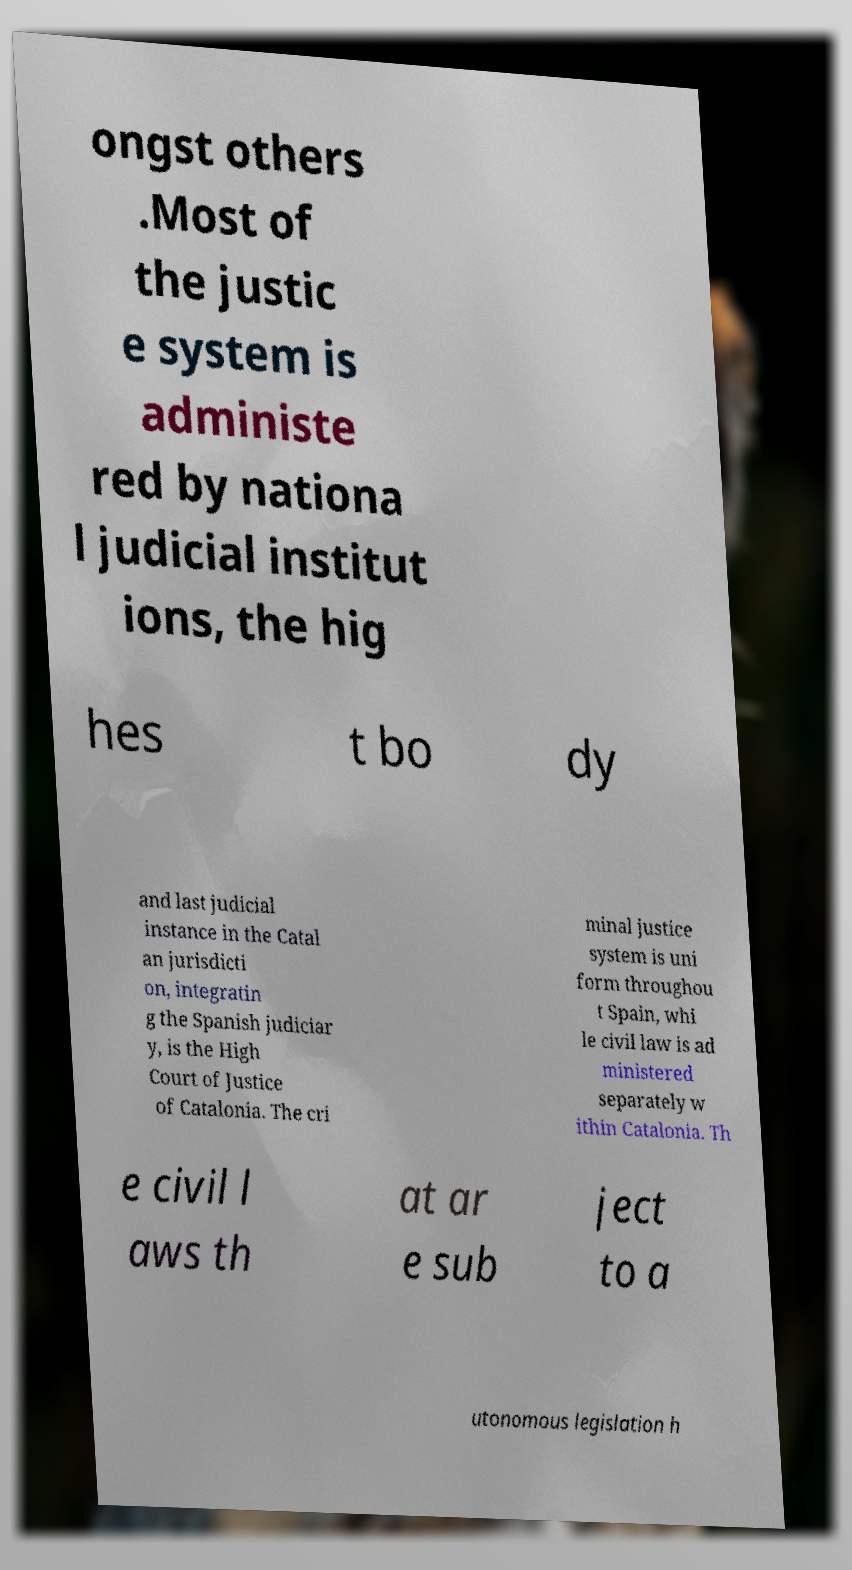Please identify and transcribe the text found in this image. ongst others .Most of the justic e system is administe red by nationa l judicial institut ions, the hig hes t bo dy and last judicial instance in the Catal an jurisdicti on, integratin g the Spanish judiciar y, is the High Court of Justice of Catalonia. The cri minal justice system is uni form throughou t Spain, whi le civil law is ad ministered separately w ithin Catalonia. Th e civil l aws th at ar e sub ject to a utonomous legislation h 